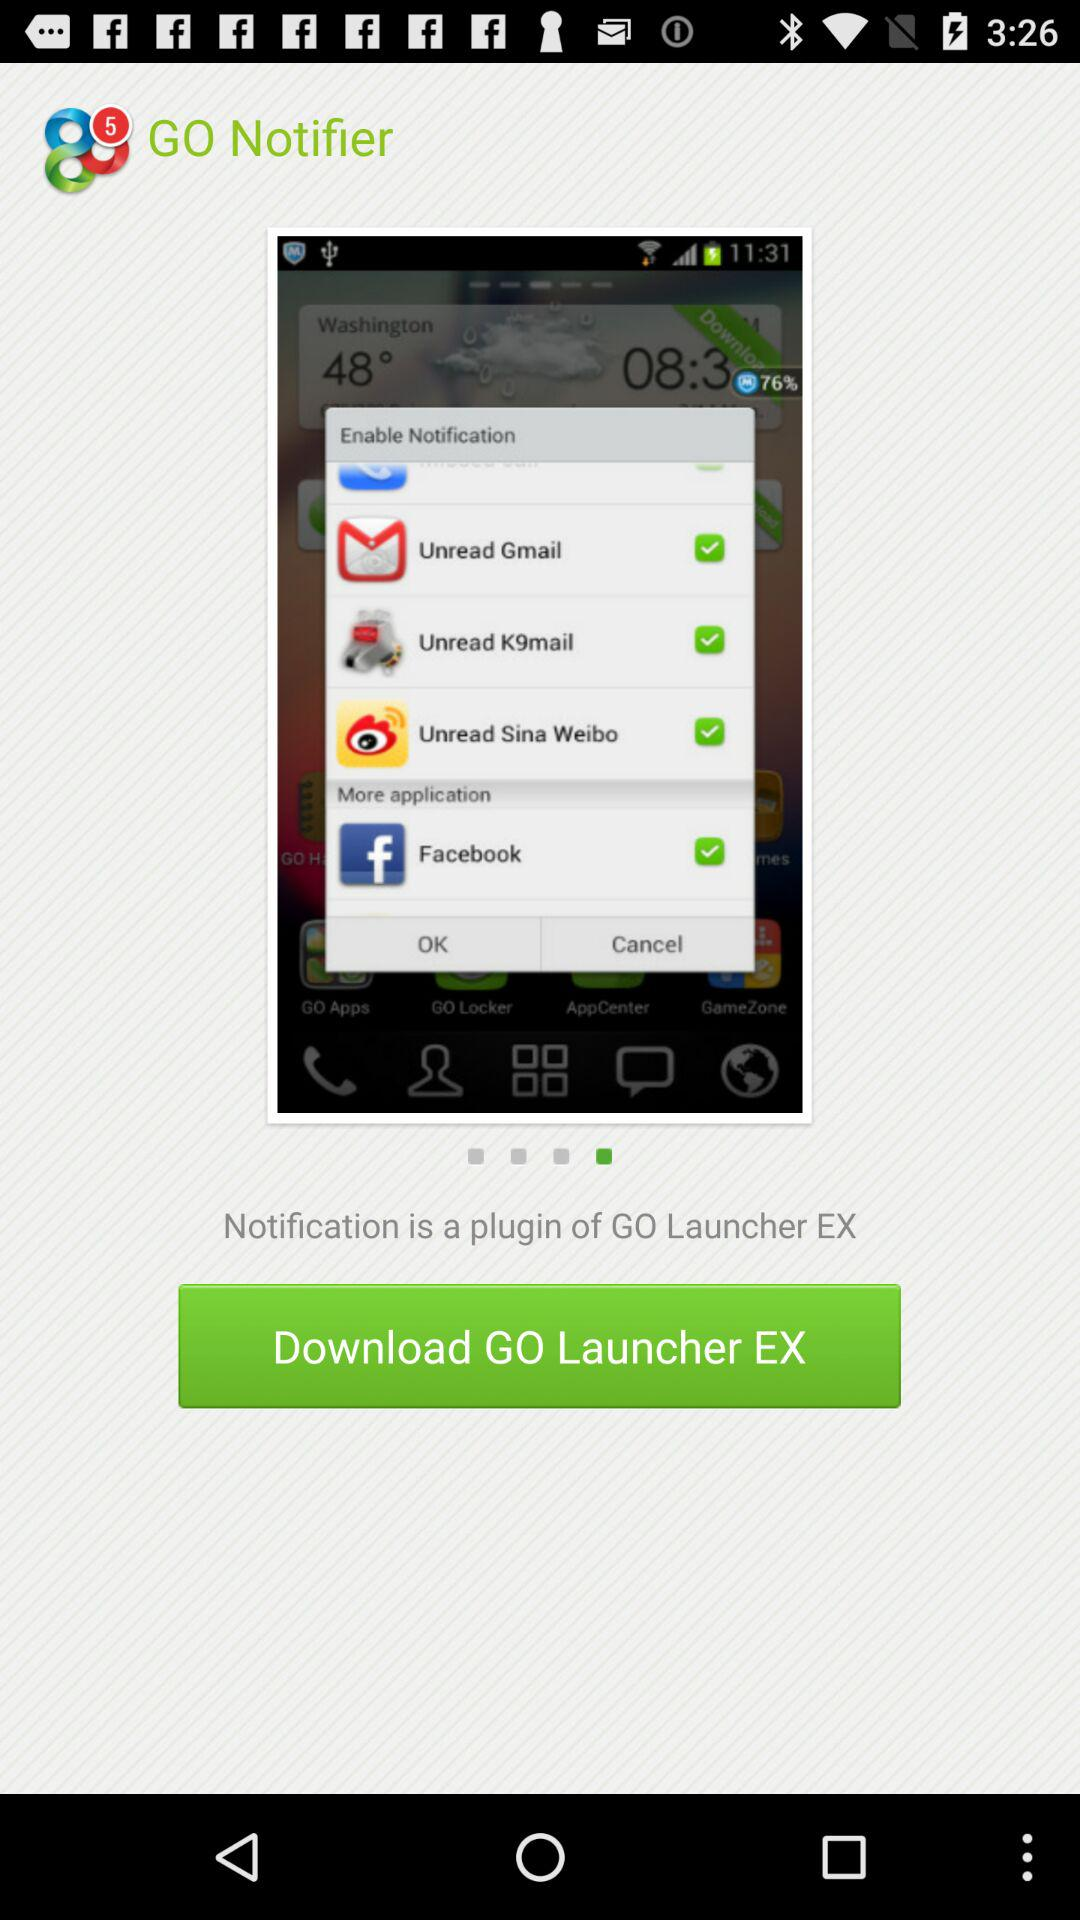How many notifications are unread?
When the provided information is insufficient, respond with <no answer>. <no answer> 